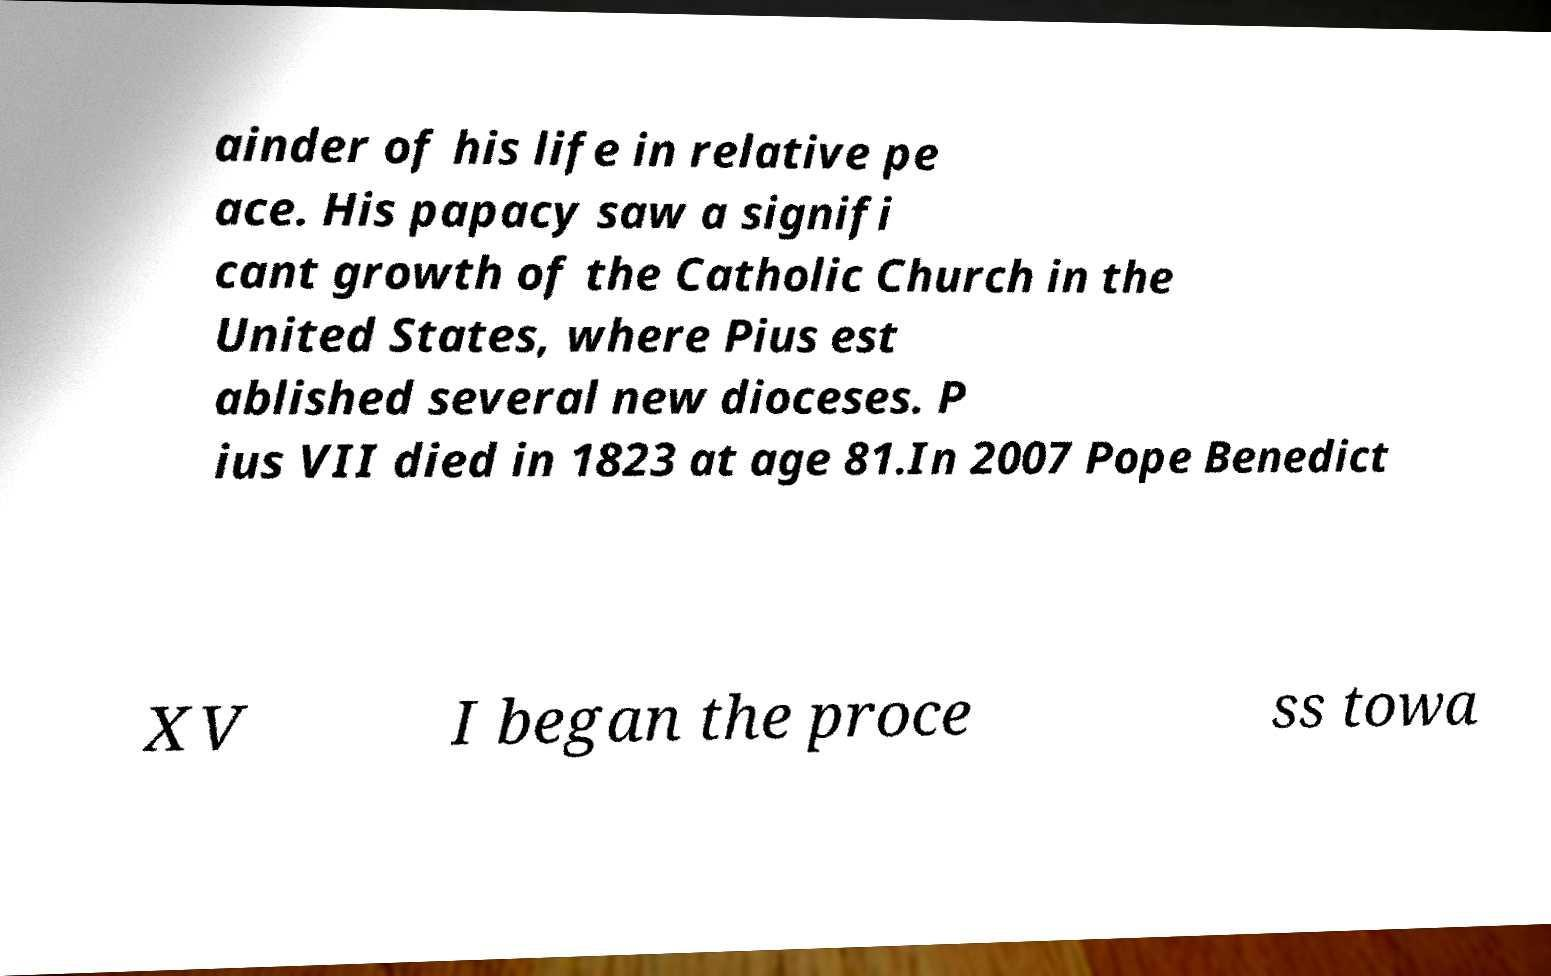There's text embedded in this image that I need extracted. Can you transcribe it verbatim? ainder of his life in relative pe ace. His papacy saw a signifi cant growth of the Catholic Church in the United States, where Pius est ablished several new dioceses. P ius VII died in 1823 at age 81.In 2007 Pope Benedict XV I began the proce ss towa 